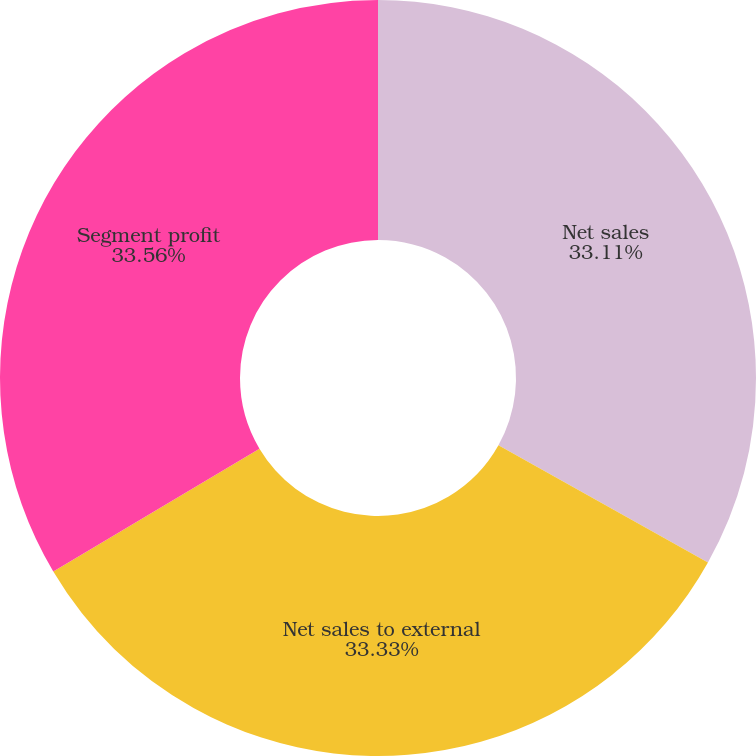Convert chart to OTSL. <chart><loc_0><loc_0><loc_500><loc_500><pie_chart><fcel>Net sales<fcel>Net sales to external<fcel>Segment profit<nl><fcel>33.11%<fcel>33.33%<fcel>33.55%<nl></chart> 